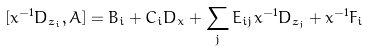Convert formula to latex. <formula><loc_0><loc_0><loc_500><loc_500>[ x ^ { - 1 } D _ { z _ { i } } , A ] = B _ { i } + C _ { i } D _ { x } + \sum _ { j } E _ { i j } x ^ { - 1 } D _ { z _ { j } } + x ^ { - 1 } F _ { i }</formula> 